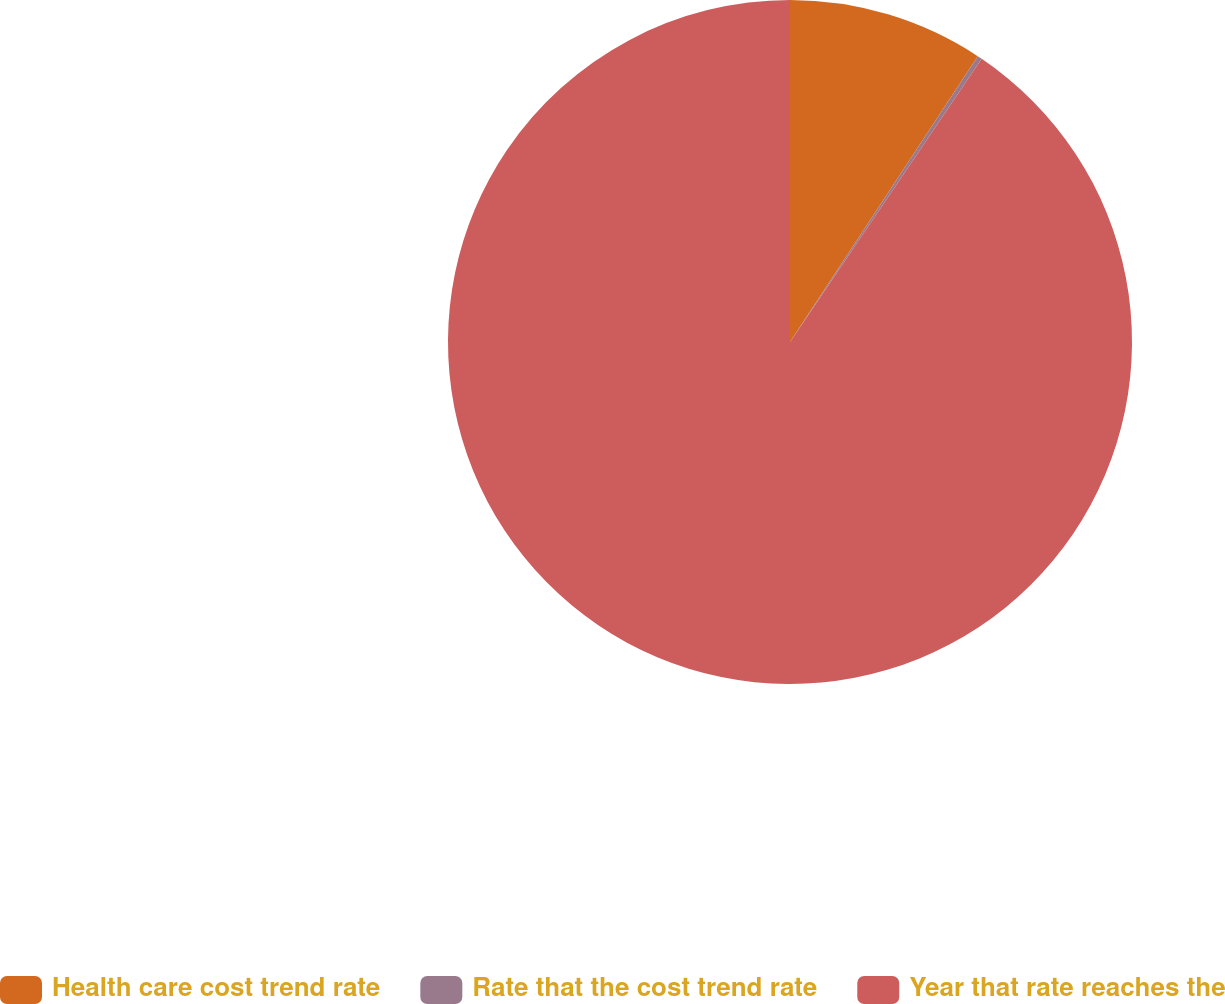Convert chart. <chart><loc_0><loc_0><loc_500><loc_500><pie_chart><fcel>Health care cost trend rate<fcel>Rate that the cost trend rate<fcel>Year that rate reaches the<nl><fcel>9.25%<fcel>0.22%<fcel>90.52%<nl></chart> 